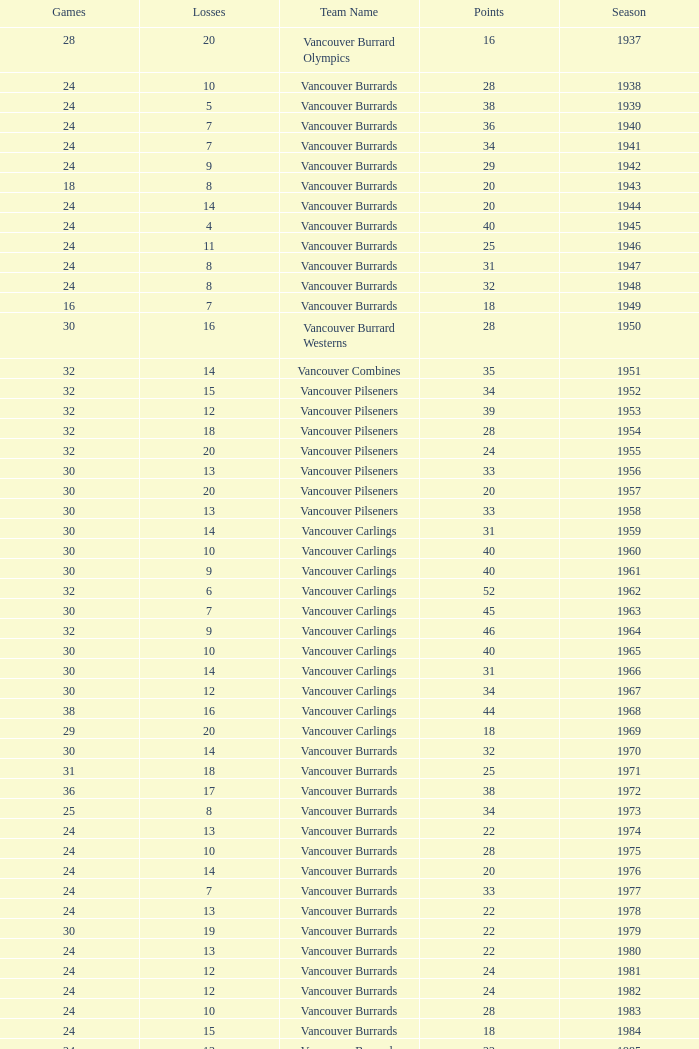What's the sum of points for the 1963 season when there are more than 30 games? None. Could you help me parse every detail presented in this table? {'header': ['Games', 'Losses', 'Team Name', 'Points', 'Season'], 'rows': [['28', '20', 'Vancouver Burrard Olympics', '16', '1937'], ['24', '10', 'Vancouver Burrards', '28', '1938'], ['24', '5', 'Vancouver Burrards', '38', '1939'], ['24', '7', 'Vancouver Burrards', '36', '1940'], ['24', '7', 'Vancouver Burrards', '34', '1941'], ['24', '9', 'Vancouver Burrards', '29', '1942'], ['18', '8', 'Vancouver Burrards', '20', '1943'], ['24', '14', 'Vancouver Burrards', '20', '1944'], ['24', '4', 'Vancouver Burrards', '40', '1945'], ['24', '11', 'Vancouver Burrards', '25', '1946'], ['24', '8', 'Vancouver Burrards', '31', '1947'], ['24', '8', 'Vancouver Burrards', '32', '1948'], ['16', '7', 'Vancouver Burrards', '18', '1949'], ['30', '16', 'Vancouver Burrard Westerns', '28', '1950'], ['32', '14', 'Vancouver Combines', '35', '1951'], ['32', '15', 'Vancouver Pilseners', '34', '1952'], ['32', '12', 'Vancouver Pilseners', '39', '1953'], ['32', '18', 'Vancouver Pilseners', '28', '1954'], ['32', '20', 'Vancouver Pilseners', '24', '1955'], ['30', '13', 'Vancouver Pilseners', '33', '1956'], ['30', '20', 'Vancouver Pilseners', '20', '1957'], ['30', '13', 'Vancouver Pilseners', '33', '1958'], ['30', '14', 'Vancouver Carlings', '31', '1959'], ['30', '10', 'Vancouver Carlings', '40', '1960'], ['30', '9', 'Vancouver Carlings', '40', '1961'], ['32', '6', 'Vancouver Carlings', '52', '1962'], ['30', '7', 'Vancouver Carlings', '45', '1963'], ['32', '9', 'Vancouver Carlings', '46', '1964'], ['30', '10', 'Vancouver Carlings', '40', '1965'], ['30', '14', 'Vancouver Carlings', '31', '1966'], ['30', '12', 'Vancouver Carlings', '34', '1967'], ['38', '16', 'Vancouver Carlings', '44', '1968'], ['29', '20', 'Vancouver Carlings', '18', '1969'], ['30', '14', 'Vancouver Burrards', '32', '1970'], ['31', '18', 'Vancouver Burrards', '25', '1971'], ['36', '17', 'Vancouver Burrards', '38', '1972'], ['25', '8', 'Vancouver Burrards', '34', '1973'], ['24', '13', 'Vancouver Burrards', '22', '1974'], ['24', '10', 'Vancouver Burrards', '28', '1975'], ['24', '14', 'Vancouver Burrards', '20', '1976'], ['24', '7', 'Vancouver Burrards', '33', '1977'], ['24', '13', 'Vancouver Burrards', '22', '1978'], ['30', '19', 'Vancouver Burrards', '22', '1979'], ['24', '13', 'Vancouver Burrards', '22', '1980'], ['24', '12', 'Vancouver Burrards', '24', '1981'], ['24', '12', 'Vancouver Burrards', '24', '1982'], ['24', '10', 'Vancouver Burrards', '28', '1983'], ['24', '15', 'Vancouver Burrards', '18', '1984'], ['24', '13', 'Vancouver Burrards', '22', '1985'], ['24', '11', 'Vancouver Burrards', '26', '1986'], ['24', '14', 'Vancouver Burrards', '20', '1987'], ['24', '13', 'Vancouver Burrards', '22', '1988'], ['24', '15', 'Vancouver Burrards', '18', '1989'], ['24', '8', 'Vancouver Burrards', '32', '1990'], ['24', '16', 'Vancouver Burrards', '16', '1991'], ['24', '15', 'Vancouver Burrards', '18', '1992'], ['24', '20', 'Vancouver Burrards', '8', '1993'], ['20', '12', 'Surrey Burrards', '16', '1994'], ['25', '19', 'Surrey Burrards', '11', '1995'], ['20', '8', 'Maple Ridge Burrards', '23', '1996'], ['20', '8', 'Maple Ridge Burrards', '23', '1997'], ['25', '8', 'Maple Ridge Burrards', '32', '1998'], ['25', '15', 'Maple Ridge Burrards', '20', '1999'], ['25', '16', 'Maple Ridge Burrards', '18', '2000'], ['20', '16', 'Maple Ridge Burrards', '8', '2001'], ['20', '15', 'Maple Ridge Burrards', '8', '2002'], ['20', '15', 'Maple Ridge Burrards', '10', '2003'], ['20', '12', 'Maple Ridge Burrards', '16', '2004'], ['18', '8', 'Maple Ridge Burrards', '19', '2005'], ['18', '11', 'Maple Ridge Burrards', '14', '2006'], ['18', '11', 'Maple Ridge Burrards', '14', '2007'], ['18', '13', 'Maple Ridge Burrards', '10', '2008'], ['18', '11', 'Maple Ridge Burrards', '14', '2009'], ['18', '9', 'Maple Ridge Burrards', '18', '2010'], ['1,879', '913', '74 seasons', '1,916', 'Total']]} 